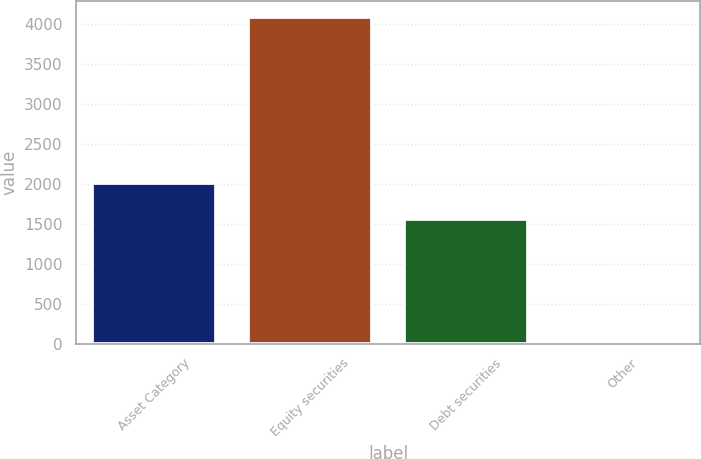Convert chart to OTSL. <chart><loc_0><loc_0><loc_500><loc_500><bar_chart><fcel>Asset Category<fcel>Equity securities<fcel>Debt securities<fcel>Other<nl><fcel>2006<fcel>4085<fcel>1560<fcel>10<nl></chart> 